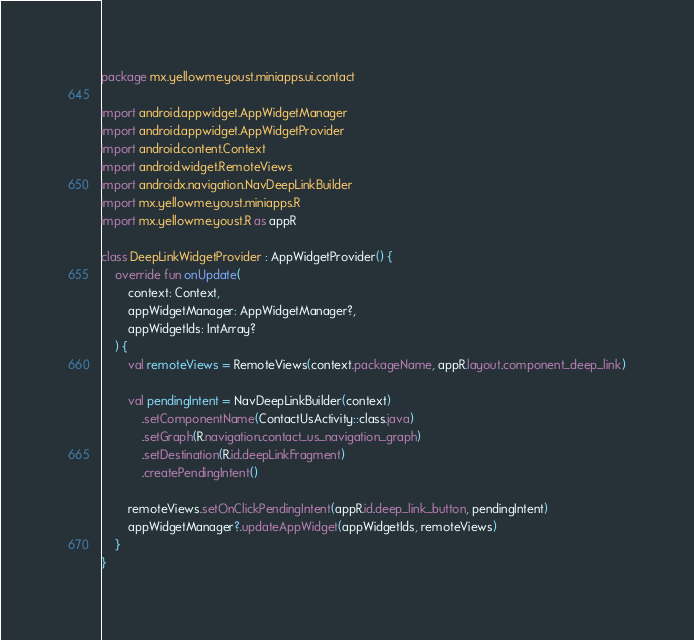<code> <loc_0><loc_0><loc_500><loc_500><_Kotlin_>package mx.yellowme.youst.miniapps.ui.contact

import android.appwidget.AppWidgetManager
import android.appwidget.AppWidgetProvider
import android.content.Context
import android.widget.RemoteViews
import androidx.navigation.NavDeepLinkBuilder
import mx.yellowme.youst.miniapps.R
import mx.yellowme.youst.R as appR

class DeepLinkWidgetProvider : AppWidgetProvider() {
    override fun onUpdate(
        context: Context,
        appWidgetManager: AppWidgetManager?,
        appWidgetIds: IntArray?
    ) {
        val remoteViews = RemoteViews(context.packageName, appR.layout.component_deep_link)

        val pendingIntent = NavDeepLinkBuilder(context)
            .setComponentName(ContactUsActivity::class.java)
            .setGraph(R.navigation.contact_us_navigation_graph)
            .setDestination(R.id.deepLinkFragment)
            .createPendingIntent()

        remoteViews.setOnClickPendingIntent(appR.id.deep_link_button, pendingIntent)
        appWidgetManager?.updateAppWidget(appWidgetIds, remoteViews)
    }
}
</code> 